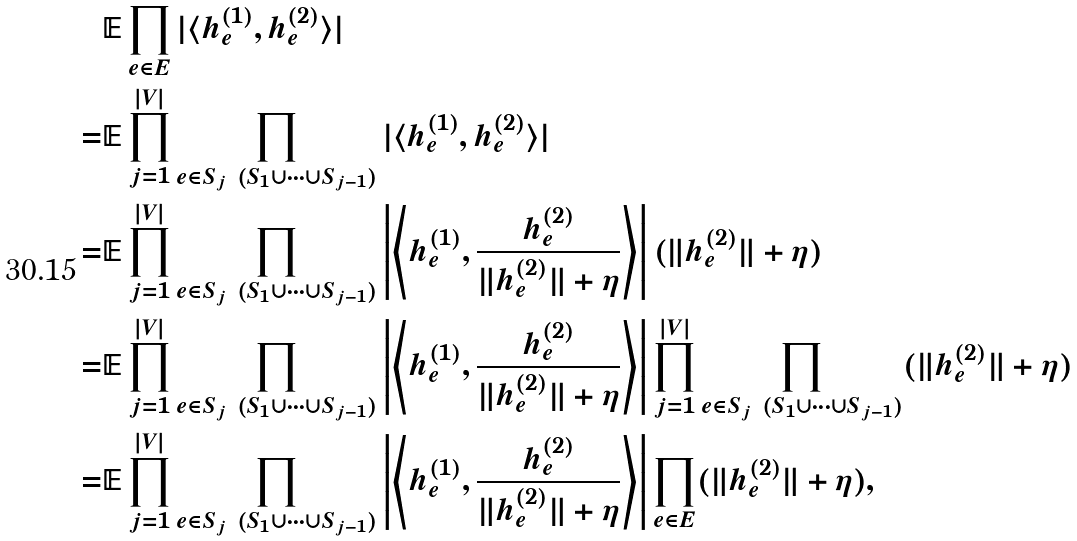<formula> <loc_0><loc_0><loc_500><loc_500>& \mathbb { E } \prod _ { e \in E } | \langle h _ { e } ^ { ( 1 ) } , h _ { e } ^ { ( 2 ) } \rangle | \\ = & \mathbb { E } \prod _ { j = 1 } ^ { | V | } \prod _ { e \in S _ { j } \ ( S _ { 1 } \cup \dots \cup S _ { j - 1 } ) } | \langle h _ { e } ^ { ( 1 ) } , h _ { e } ^ { ( 2 ) } \rangle | \\ = & \mathbb { E } \prod _ { j = 1 } ^ { | V | } \prod _ { e \in S _ { j } \ ( S _ { 1 } \cup \dots \cup S _ { j - 1 } ) } \left | \left \langle h _ { e } ^ { ( 1 ) } , \frac { h _ { e } ^ { ( 2 ) } } { \| h _ { e } ^ { ( 2 ) } \| + \eta } \right \rangle \right | ( \| h _ { e } ^ { ( 2 ) } \| + \eta ) \\ = & \mathbb { E } \prod _ { j = 1 } ^ { | V | } \prod _ { e \in S _ { j } \ ( S _ { 1 } \cup \dots \cup S _ { j - 1 } ) } \left | \left \langle h _ { e } ^ { ( 1 ) } , \frac { h _ { e } ^ { ( 2 ) } } { \| h _ { e } ^ { ( 2 ) } \| + \eta } \right \rangle \right | \prod _ { j = 1 } ^ { | V | } \prod _ { e \in S _ { j } \ ( S _ { 1 } \cup \dots \cup S _ { j - 1 } ) } ( \| h _ { e } ^ { ( 2 ) } \| + \eta ) \\ = & \mathbb { E } \prod _ { j = 1 } ^ { | V | } \prod _ { e \in S _ { j } \ ( S _ { 1 } \cup \dots \cup S _ { j - 1 } ) } \left | \left \langle h _ { e } ^ { ( 1 ) } , \frac { h _ { e } ^ { ( 2 ) } } { \| h _ { e } ^ { ( 2 ) } \| + \eta } \right \rangle \right | \prod _ { e \in E } ( \| h _ { e } ^ { ( 2 ) } \| + \eta ) ,</formula> 